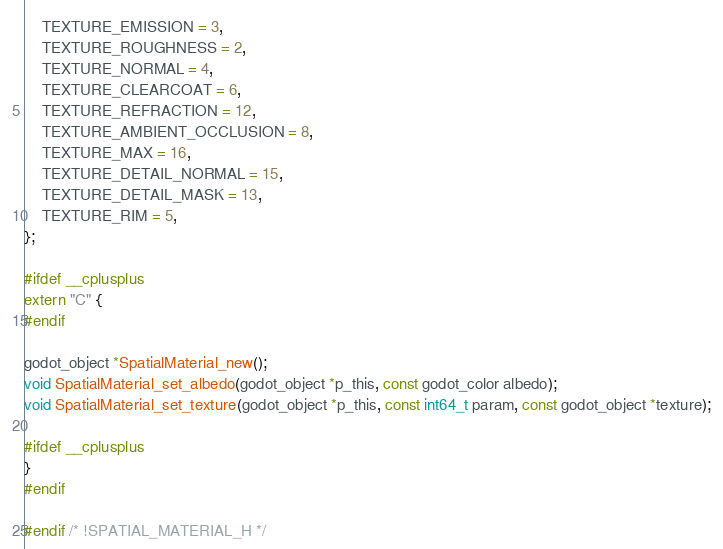<code> <loc_0><loc_0><loc_500><loc_500><_C_>	TEXTURE_EMISSION = 3,
	TEXTURE_ROUGHNESS = 2,
	TEXTURE_NORMAL = 4,
	TEXTURE_CLEARCOAT = 6,
	TEXTURE_REFRACTION = 12,
	TEXTURE_AMBIENT_OCCLUSION = 8,
	TEXTURE_MAX = 16,
	TEXTURE_DETAIL_NORMAL = 15,
	TEXTURE_DETAIL_MASK = 13,
	TEXTURE_RIM = 5,
};

#ifdef __cplusplus
extern "C" {
#endif

godot_object *SpatialMaterial_new();
void SpatialMaterial_set_albedo(godot_object *p_this, const godot_color albedo);
void SpatialMaterial_set_texture(godot_object *p_this, const int64_t param, const godot_object *texture);

#ifdef __cplusplus
}
#endif

#endif /* !SPATIAL_MATERIAL_H */
</code> 